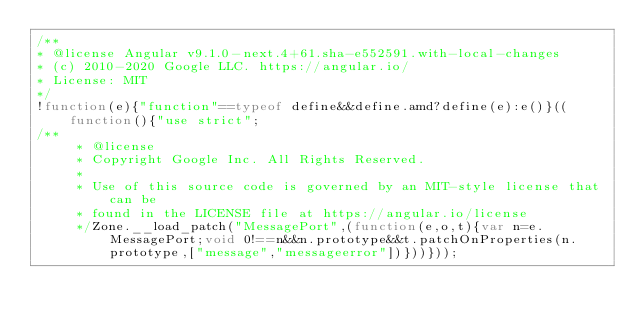Convert code to text. <code><loc_0><loc_0><loc_500><loc_500><_JavaScript_>/**
* @license Angular v9.1.0-next.4+61.sha-e552591.with-local-changes
* (c) 2010-2020 Google LLC. https://angular.io/
* License: MIT
*/
!function(e){"function"==typeof define&&define.amd?define(e):e()}((function(){"use strict";
/**
     * @license
     * Copyright Google Inc. All Rights Reserved.
     *
     * Use of this source code is governed by an MIT-style license that can be
     * found in the LICENSE file at https://angular.io/license
     */Zone.__load_patch("MessagePort",(function(e,o,t){var n=e.MessagePort;void 0!==n&&n.prototype&&t.patchOnProperties(n.prototype,["message","messageerror"])}))}));</code> 